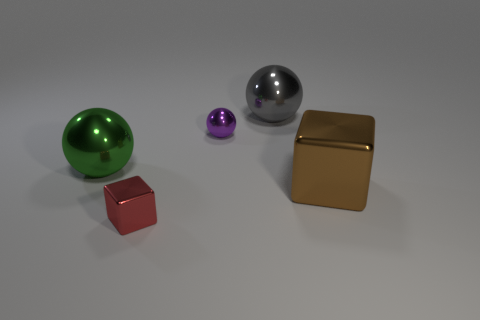What number of things are either tiny yellow metal objects or brown things?
Make the answer very short. 1. Are there any gray spheres made of the same material as the big green ball?
Offer a terse response. Yes. There is a tiny thing behind the large thing left of the red thing; what color is it?
Your answer should be compact. Purple. Does the purple object have the same size as the gray sphere?
Provide a succinct answer. No. What number of spheres are large gray things or small red metallic objects?
Provide a short and direct response. 1. There is a big metal sphere on the right side of the green sphere; what number of red shiny objects are in front of it?
Offer a very short reply. 1. Is the shape of the large gray thing the same as the purple object?
Provide a short and direct response. Yes. The purple thing that is the same shape as the big green thing is what size?
Offer a very short reply. Small. There is a big metal object that is to the left of the metal sphere on the right side of the tiny purple object; what is its shape?
Make the answer very short. Sphere. The brown thing is what size?
Your answer should be compact. Large. 